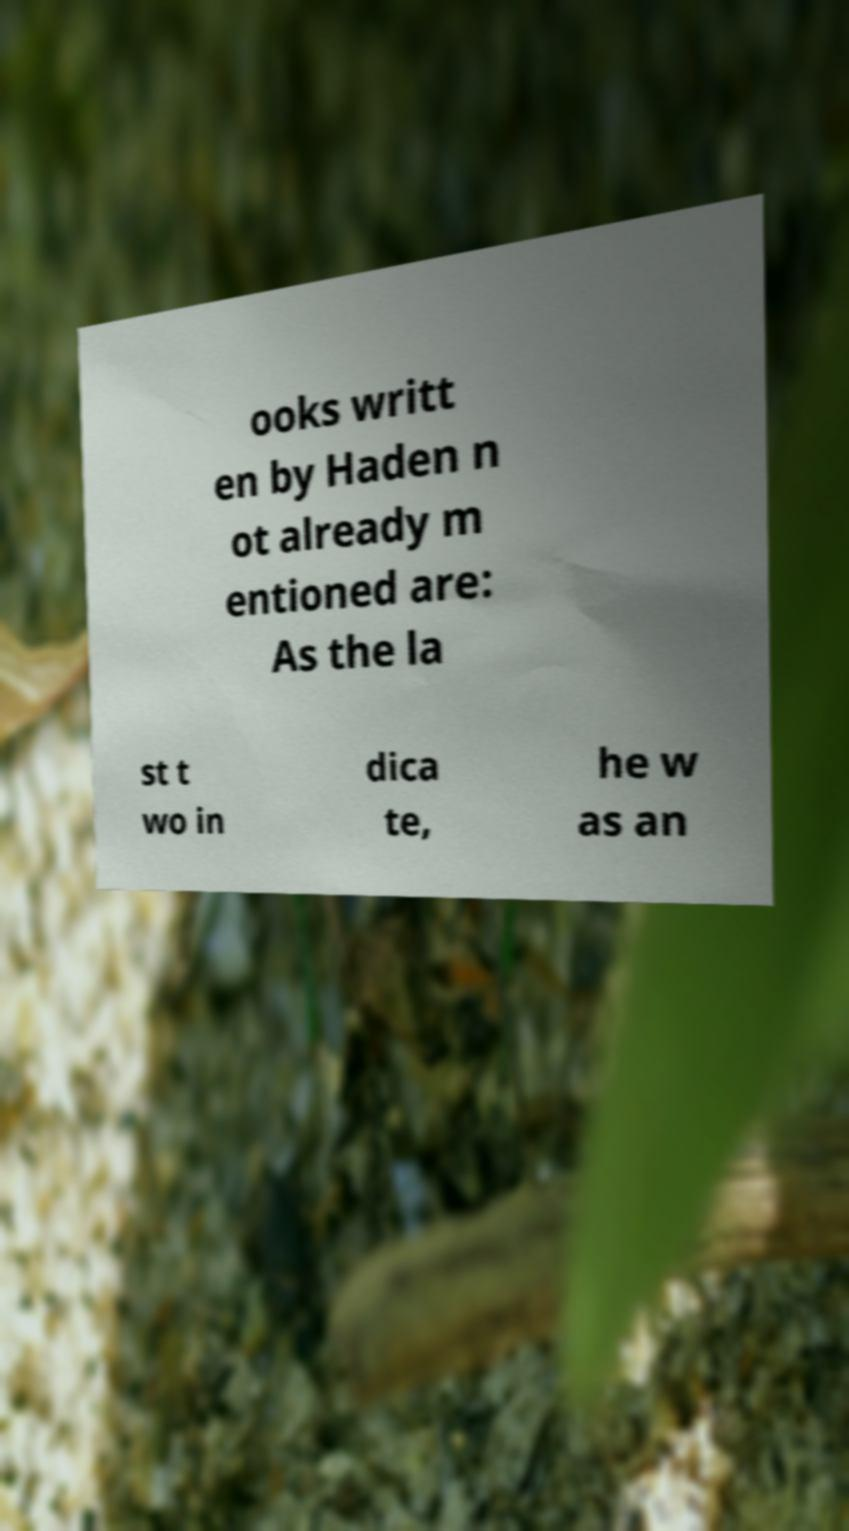Could you assist in decoding the text presented in this image and type it out clearly? ooks writt en by Haden n ot already m entioned are: As the la st t wo in dica te, he w as an 